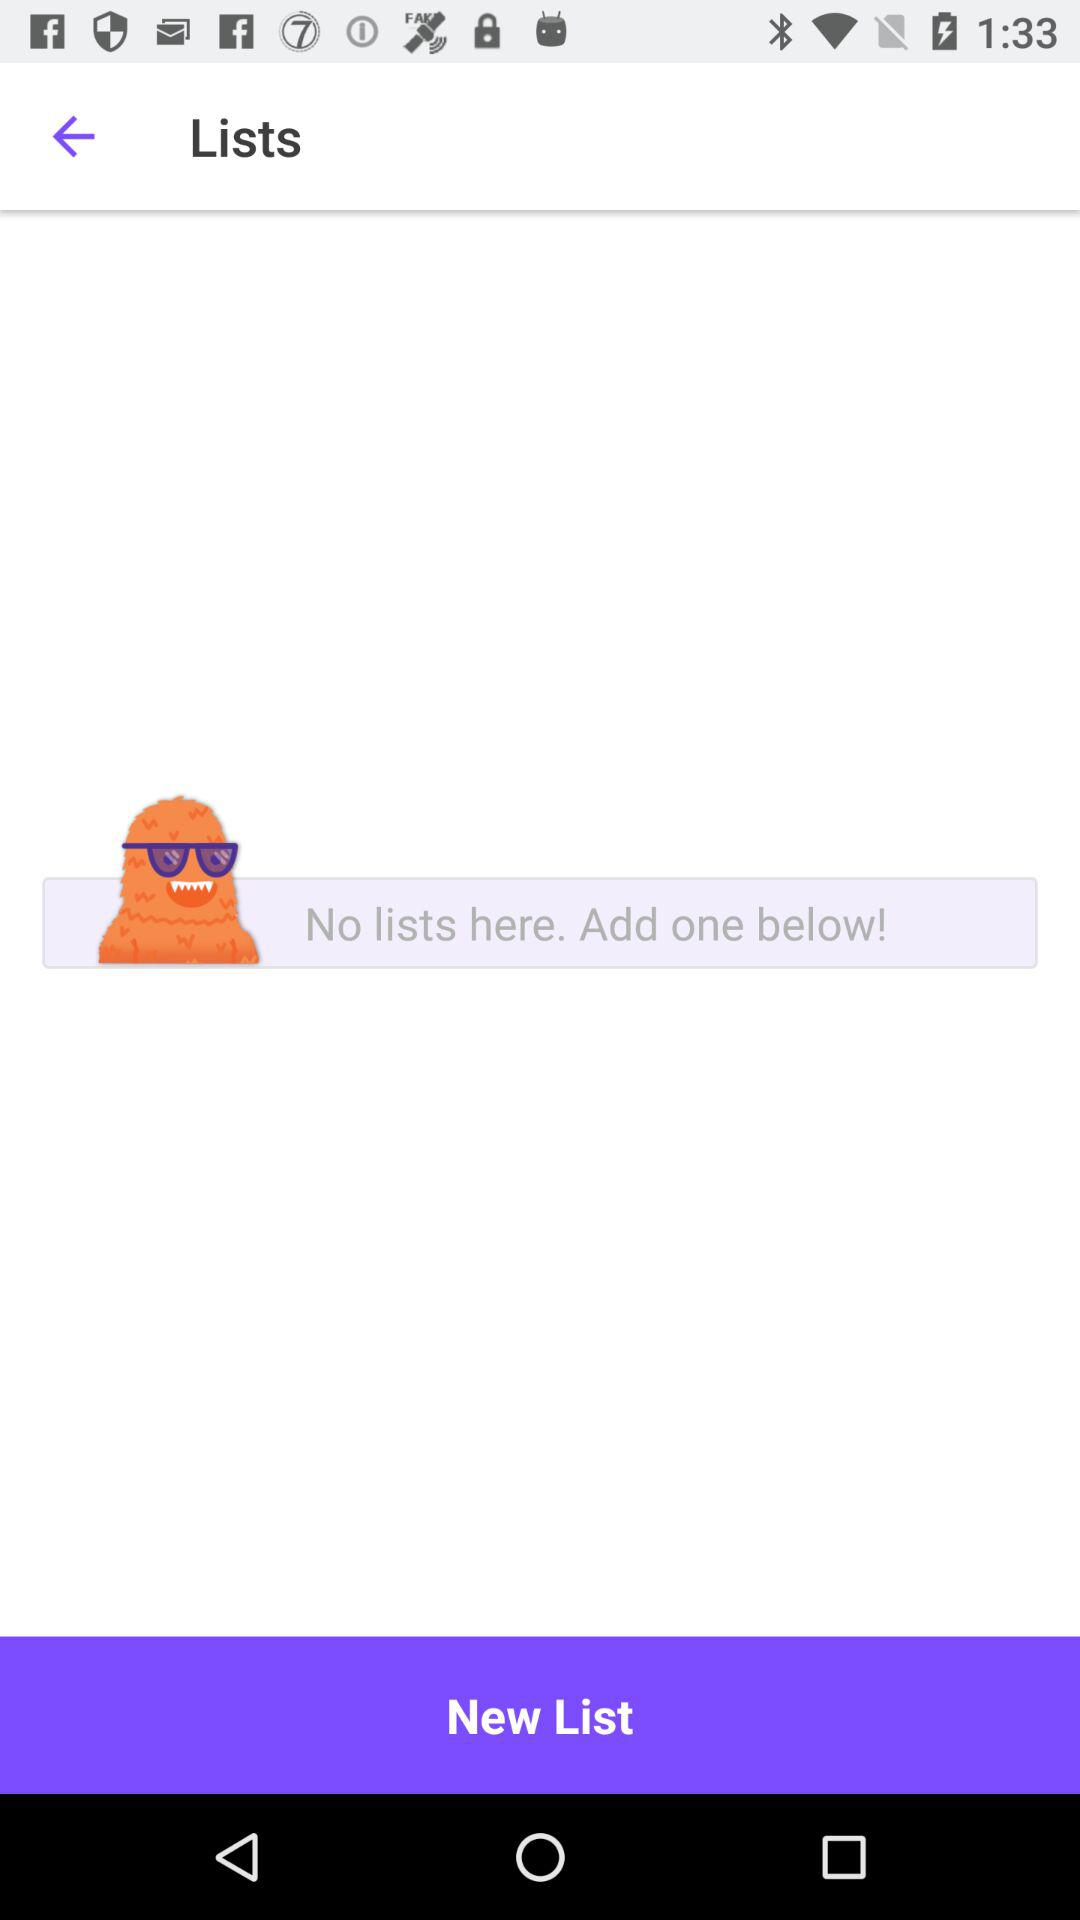Is there any list? There is no list. 